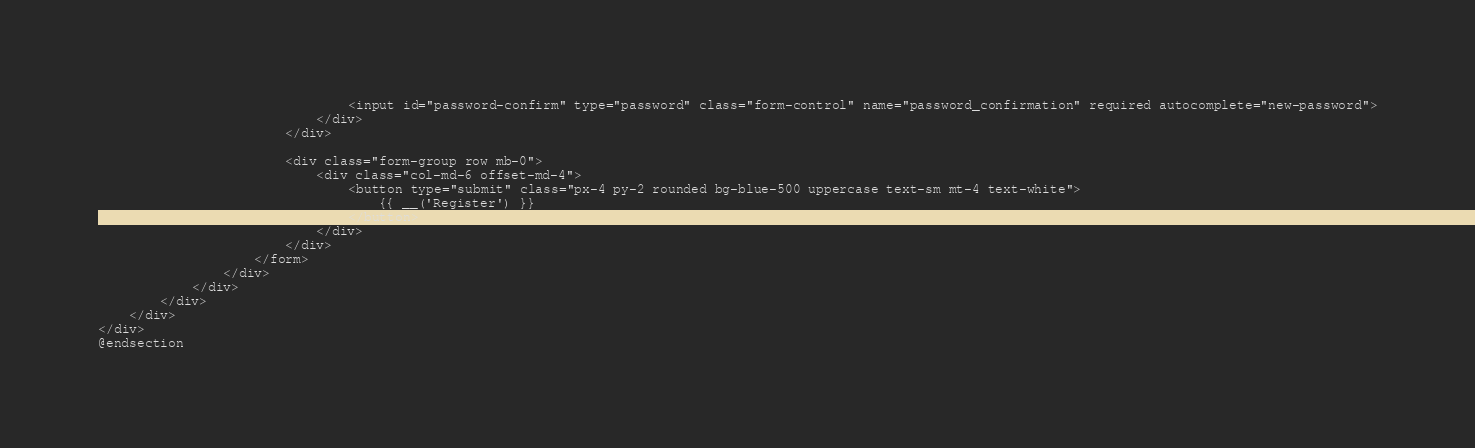Convert code to text. <code><loc_0><loc_0><loc_500><loc_500><_PHP_>                                <input id="password-confirm" type="password" class="form-control" name="password_confirmation" required autocomplete="new-password">
                            </div>
                        </div>

                        <div class="form-group row mb-0">
                            <div class="col-md-6 offset-md-4">
                                <button type="submit" class="px-4 py-2 rounded bg-blue-500 uppercase text-sm mt-4 text-white">
                                    {{ __('Register') }}
                                </button>
                            </div>
                        </div>
                    </form>
                </div>
            </div>
        </div>
    </div>
</div>
@endsection
</code> 